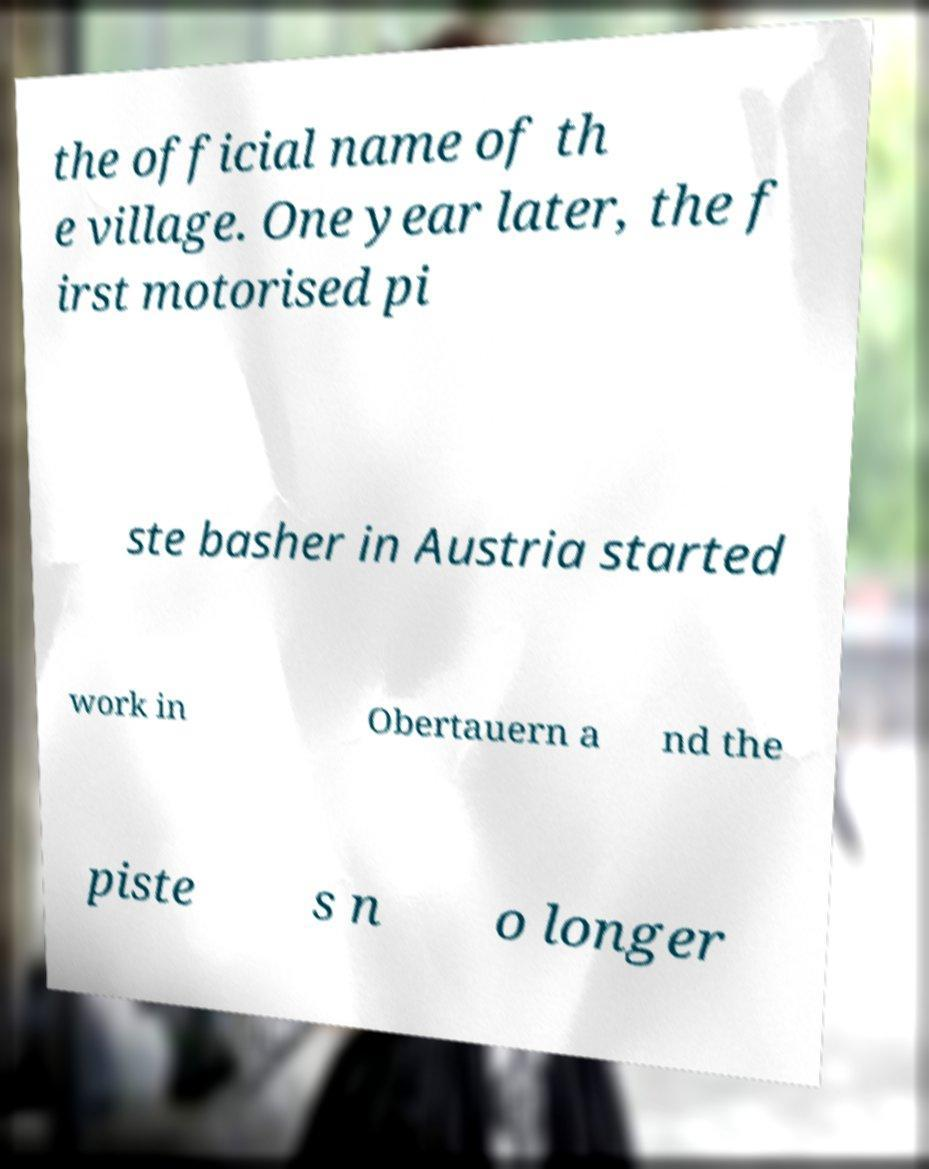For documentation purposes, I need the text within this image transcribed. Could you provide that? the official name of th e village. One year later, the f irst motorised pi ste basher in Austria started work in Obertauern a nd the piste s n o longer 